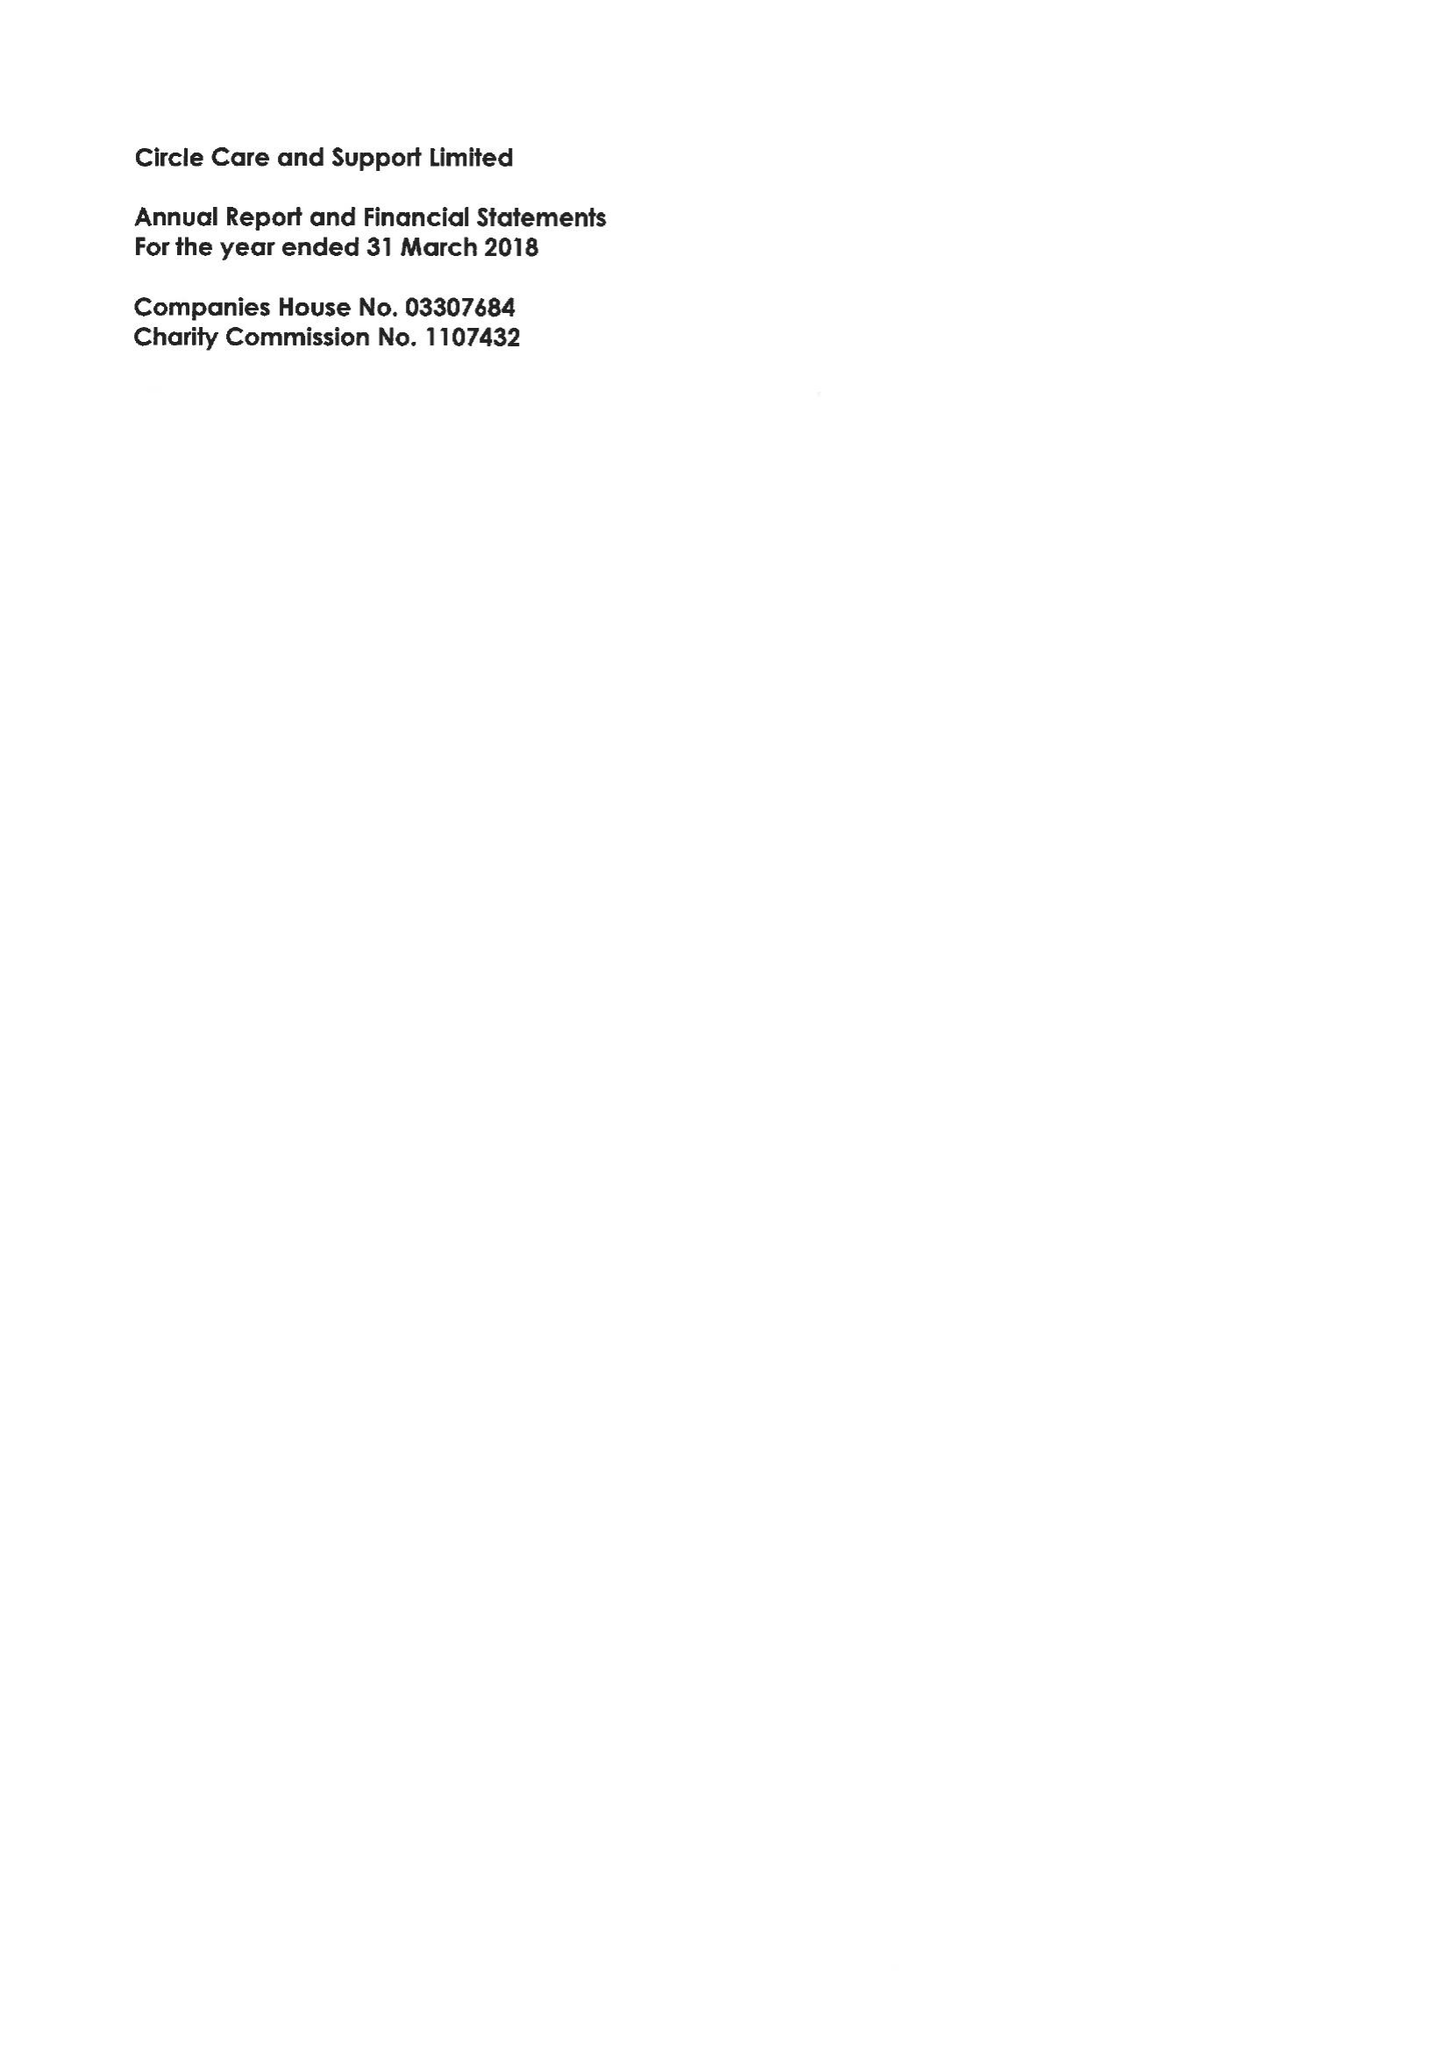What is the value for the address__postcode?
Answer the question using a single word or phrase. SE1 2DA 